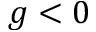<formula> <loc_0><loc_0><loc_500><loc_500>g < 0</formula> 